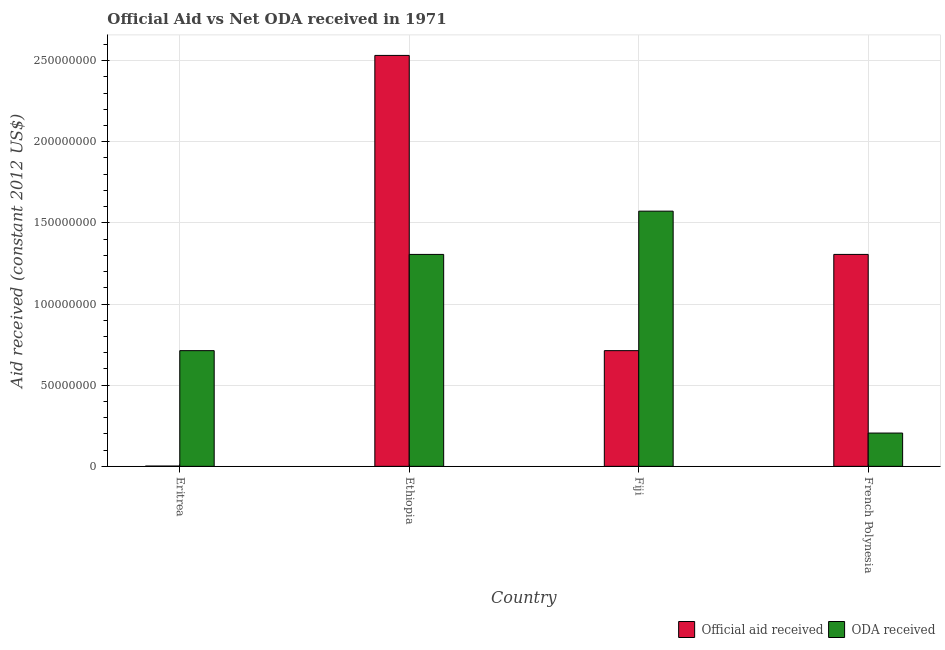How many different coloured bars are there?
Ensure brevity in your answer.  2. Are the number of bars per tick equal to the number of legend labels?
Give a very brief answer. Yes. How many bars are there on the 3rd tick from the left?
Your response must be concise. 2. What is the label of the 1st group of bars from the left?
Give a very brief answer. Eritrea. What is the official aid received in French Polynesia?
Your answer should be very brief. 1.31e+08. Across all countries, what is the maximum official aid received?
Offer a terse response. 2.53e+08. Across all countries, what is the minimum oda received?
Offer a very short reply. 2.05e+07. In which country was the oda received maximum?
Ensure brevity in your answer.  Fiji. In which country was the official aid received minimum?
Provide a short and direct response. Eritrea. What is the total oda received in the graph?
Give a very brief answer. 3.80e+08. What is the difference between the oda received in Fiji and that in French Polynesia?
Make the answer very short. 1.37e+08. What is the difference between the official aid received in Fiji and the oda received in Ethiopia?
Your response must be concise. -5.93e+07. What is the average oda received per country?
Your response must be concise. 9.49e+07. What is the difference between the oda received and official aid received in French Polynesia?
Offer a very short reply. -1.10e+08. What is the ratio of the official aid received in Fiji to that in French Polynesia?
Offer a terse response. 0.55. What is the difference between the highest and the second highest official aid received?
Keep it short and to the point. 1.23e+08. What is the difference between the highest and the lowest official aid received?
Offer a terse response. 2.53e+08. What does the 1st bar from the left in Ethiopia represents?
Your answer should be very brief. Official aid received. What does the 2nd bar from the right in Eritrea represents?
Give a very brief answer. Official aid received. Are all the bars in the graph horizontal?
Offer a terse response. No. How many countries are there in the graph?
Your response must be concise. 4. What is the difference between two consecutive major ticks on the Y-axis?
Give a very brief answer. 5.00e+07. How many legend labels are there?
Keep it short and to the point. 2. What is the title of the graph?
Provide a succinct answer. Official Aid vs Net ODA received in 1971 . What is the label or title of the Y-axis?
Offer a very short reply. Aid received (constant 2012 US$). What is the Aid received (constant 2012 US$) of Official aid received in Eritrea?
Make the answer very short. 1.80e+05. What is the Aid received (constant 2012 US$) of ODA received in Eritrea?
Your answer should be very brief. 7.13e+07. What is the Aid received (constant 2012 US$) of Official aid received in Ethiopia?
Your answer should be compact. 2.53e+08. What is the Aid received (constant 2012 US$) of ODA received in Ethiopia?
Offer a very short reply. 1.31e+08. What is the Aid received (constant 2012 US$) of Official aid received in Fiji?
Offer a very short reply. 7.13e+07. What is the Aid received (constant 2012 US$) in ODA received in Fiji?
Your answer should be compact. 1.57e+08. What is the Aid received (constant 2012 US$) in Official aid received in French Polynesia?
Give a very brief answer. 1.31e+08. What is the Aid received (constant 2012 US$) in ODA received in French Polynesia?
Offer a very short reply. 2.05e+07. Across all countries, what is the maximum Aid received (constant 2012 US$) in Official aid received?
Make the answer very short. 2.53e+08. Across all countries, what is the maximum Aid received (constant 2012 US$) in ODA received?
Your response must be concise. 1.57e+08. Across all countries, what is the minimum Aid received (constant 2012 US$) of ODA received?
Make the answer very short. 2.05e+07. What is the total Aid received (constant 2012 US$) in Official aid received in the graph?
Provide a short and direct response. 4.55e+08. What is the total Aid received (constant 2012 US$) in ODA received in the graph?
Ensure brevity in your answer.  3.80e+08. What is the difference between the Aid received (constant 2012 US$) of Official aid received in Eritrea and that in Ethiopia?
Your response must be concise. -2.53e+08. What is the difference between the Aid received (constant 2012 US$) of ODA received in Eritrea and that in Ethiopia?
Ensure brevity in your answer.  -5.93e+07. What is the difference between the Aid received (constant 2012 US$) of Official aid received in Eritrea and that in Fiji?
Ensure brevity in your answer.  -7.11e+07. What is the difference between the Aid received (constant 2012 US$) in ODA received in Eritrea and that in Fiji?
Give a very brief answer. -8.60e+07. What is the difference between the Aid received (constant 2012 US$) of Official aid received in Eritrea and that in French Polynesia?
Offer a terse response. -1.30e+08. What is the difference between the Aid received (constant 2012 US$) of ODA received in Eritrea and that in French Polynesia?
Your answer should be compact. 5.08e+07. What is the difference between the Aid received (constant 2012 US$) of Official aid received in Ethiopia and that in Fiji?
Give a very brief answer. 1.82e+08. What is the difference between the Aid received (constant 2012 US$) of ODA received in Ethiopia and that in Fiji?
Provide a short and direct response. -2.67e+07. What is the difference between the Aid received (constant 2012 US$) of Official aid received in Ethiopia and that in French Polynesia?
Keep it short and to the point. 1.23e+08. What is the difference between the Aid received (constant 2012 US$) of ODA received in Ethiopia and that in French Polynesia?
Offer a very short reply. 1.10e+08. What is the difference between the Aid received (constant 2012 US$) of Official aid received in Fiji and that in French Polynesia?
Offer a very short reply. -5.93e+07. What is the difference between the Aid received (constant 2012 US$) of ODA received in Fiji and that in French Polynesia?
Provide a short and direct response. 1.37e+08. What is the difference between the Aid received (constant 2012 US$) of Official aid received in Eritrea and the Aid received (constant 2012 US$) of ODA received in Ethiopia?
Give a very brief answer. -1.30e+08. What is the difference between the Aid received (constant 2012 US$) in Official aid received in Eritrea and the Aid received (constant 2012 US$) in ODA received in Fiji?
Provide a short and direct response. -1.57e+08. What is the difference between the Aid received (constant 2012 US$) in Official aid received in Eritrea and the Aid received (constant 2012 US$) in ODA received in French Polynesia?
Provide a succinct answer. -2.03e+07. What is the difference between the Aid received (constant 2012 US$) in Official aid received in Ethiopia and the Aid received (constant 2012 US$) in ODA received in Fiji?
Your response must be concise. 9.59e+07. What is the difference between the Aid received (constant 2012 US$) in Official aid received in Ethiopia and the Aid received (constant 2012 US$) in ODA received in French Polynesia?
Provide a succinct answer. 2.33e+08. What is the difference between the Aid received (constant 2012 US$) in Official aid received in Fiji and the Aid received (constant 2012 US$) in ODA received in French Polynesia?
Provide a succinct answer. 5.08e+07. What is the average Aid received (constant 2012 US$) of Official aid received per country?
Your response must be concise. 1.14e+08. What is the average Aid received (constant 2012 US$) in ODA received per country?
Give a very brief answer. 9.49e+07. What is the difference between the Aid received (constant 2012 US$) of Official aid received and Aid received (constant 2012 US$) of ODA received in Eritrea?
Offer a terse response. -7.11e+07. What is the difference between the Aid received (constant 2012 US$) in Official aid received and Aid received (constant 2012 US$) in ODA received in Ethiopia?
Offer a terse response. 1.23e+08. What is the difference between the Aid received (constant 2012 US$) in Official aid received and Aid received (constant 2012 US$) in ODA received in Fiji?
Keep it short and to the point. -8.60e+07. What is the difference between the Aid received (constant 2012 US$) in Official aid received and Aid received (constant 2012 US$) in ODA received in French Polynesia?
Provide a succinct answer. 1.10e+08. What is the ratio of the Aid received (constant 2012 US$) of Official aid received in Eritrea to that in Ethiopia?
Keep it short and to the point. 0. What is the ratio of the Aid received (constant 2012 US$) in ODA received in Eritrea to that in Ethiopia?
Give a very brief answer. 0.55. What is the ratio of the Aid received (constant 2012 US$) in Official aid received in Eritrea to that in Fiji?
Keep it short and to the point. 0. What is the ratio of the Aid received (constant 2012 US$) in ODA received in Eritrea to that in Fiji?
Keep it short and to the point. 0.45. What is the ratio of the Aid received (constant 2012 US$) of Official aid received in Eritrea to that in French Polynesia?
Offer a very short reply. 0. What is the ratio of the Aid received (constant 2012 US$) in ODA received in Eritrea to that in French Polynesia?
Offer a terse response. 3.48. What is the ratio of the Aid received (constant 2012 US$) of Official aid received in Ethiopia to that in Fiji?
Your response must be concise. 3.55. What is the ratio of the Aid received (constant 2012 US$) of ODA received in Ethiopia to that in Fiji?
Ensure brevity in your answer.  0.83. What is the ratio of the Aid received (constant 2012 US$) of Official aid received in Ethiopia to that in French Polynesia?
Give a very brief answer. 1.94. What is the ratio of the Aid received (constant 2012 US$) of ODA received in Ethiopia to that in French Polynesia?
Ensure brevity in your answer.  6.37. What is the ratio of the Aid received (constant 2012 US$) of Official aid received in Fiji to that in French Polynesia?
Provide a succinct answer. 0.55. What is the ratio of the Aid received (constant 2012 US$) in ODA received in Fiji to that in French Polynesia?
Provide a short and direct response. 7.67. What is the difference between the highest and the second highest Aid received (constant 2012 US$) in Official aid received?
Make the answer very short. 1.23e+08. What is the difference between the highest and the second highest Aid received (constant 2012 US$) in ODA received?
Your response must be concise. 2.67e+07. What is the difference between the highest and the lowest Aid received (constant 2012 US$) in Official aid received?
Keep it short and to the point. 2.53e+08. What is the difference between the highest and the lowest Aid received (constant 2012 US$) of ODA received?
Your answer should be very brief. 1.37e+08. 